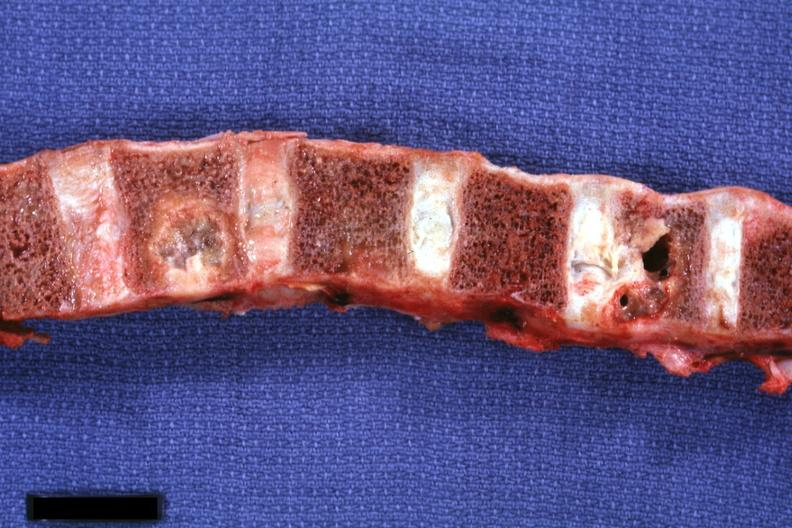does this image show sectioned vertebral bodies showing very nicely osteolytic metastatic lesions primary squamous cell carcinoma penis?
Answer the question using a single word or phrase. Yes 